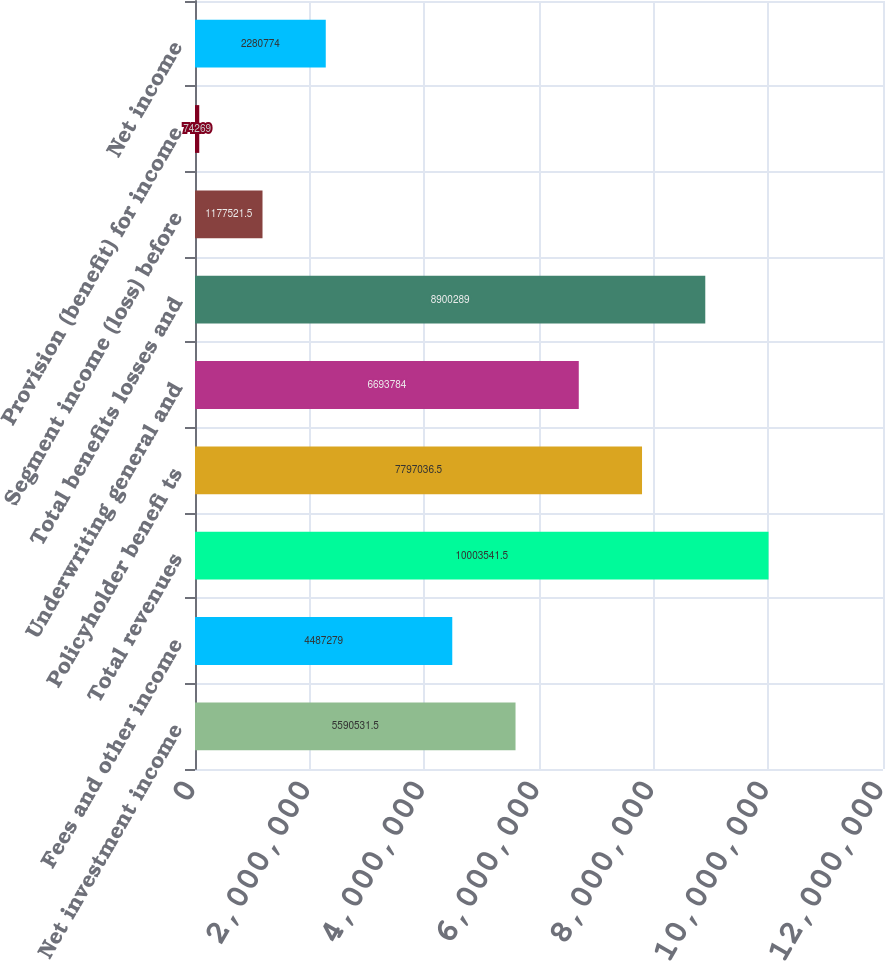<chart> <loc_0><loc_0><loc_500><loc_500><bar_chart><fcel>Net investment income<fcel>Fees and other income<fcel>Total revenues<fcel>Policyholder benefi ts<fcel>Underwriting general and<fcel>Total benefits losses and<fcel>Segment income (loss) before<fcel>Provision (benefit) for income<fcel>Net income<nl><fcel>5.59053e+06<fcel>4.48728e+06<fcel>1.00035e+07<fcel>7.79704e+06<fcel>6.69378e+06<fcel>8.90029e+06<fcel>1.17752e+06<fcel>74269<fcel>2.28077e+06<nl></chart> 